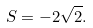Convert formula to latex. <formula><loc_0><loc_0><loc_500><loc_500>S = - 2 { \sqrt { 2 } } .</formula> 